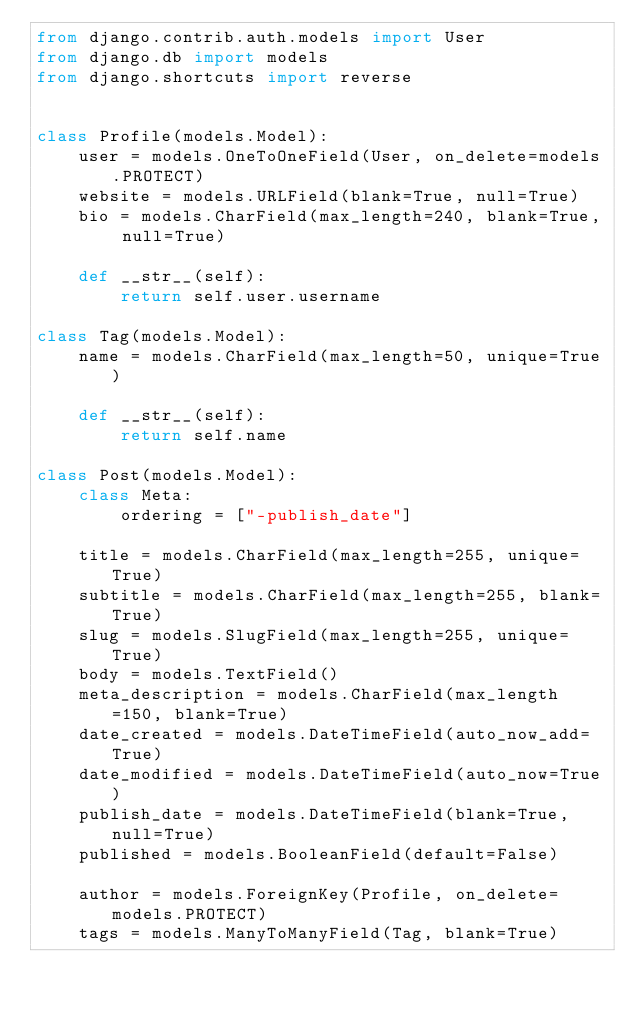<code> <loc_0><loc_0><loc_500><loc_500><_Python_>from django.contrib.auth.models import User
from django.db import models
from django.shortcuts import reverse


class Profile(models.Model):
    user = models.OneToOneField(User, on_delete=models.PROTECT)
    website = models.URLField(blank=True, null=True)
    bio = models.CharField(max_length=240, blank=True, null=True)

    def __str__(self):
        return self.user.username

class Tag(models.Model):
    name = models.CharField(max_length=50, unique=True)

    def __str__(self):
        return self.name

class Post(models.Model):
    class Meta:
        ordering = ["-publish_date"]

    title = models.CharField(max_length=255, unique=True)
    subtitle = models.CharField(max_length=255, blank=True)
    slug = models.SlugField(max_length=255, unique=True)
    body = models.TextField()
    meta_description = models.CharField(max_length=150, blank=True)
    date_created = models.DateTimeField(auto_now_add=True)
    date_modified = models.DateTimeField(auto_now=True)
    publish_date = models.DateTimeField(blank=True, null=True)
    published = models.BooleanField(default=False)

    author = models.ForeignKey(Profile, on_delete=models.PROTECT)
    tags = models.ManyToManyField(Tag, blank=True)</code> 